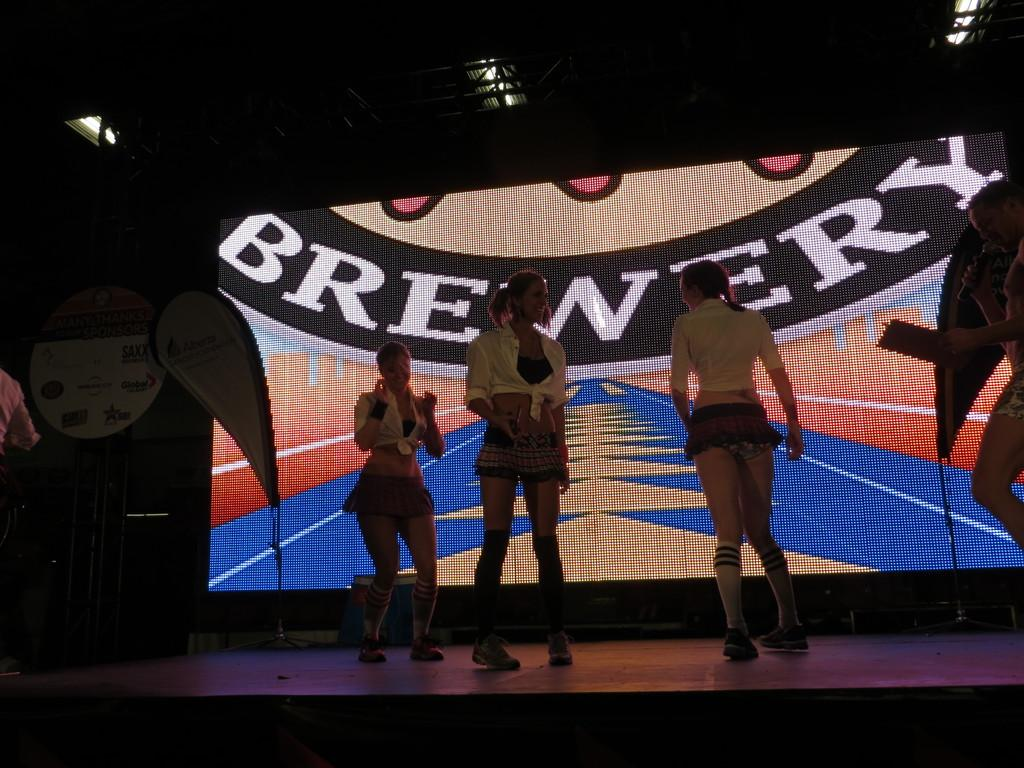What is happening on the stage in the image? There are women on the stage in the image. What is the person holding in his hand? The person is holding a mic and a paper in his hand. What can be seen hanging in the background? There are banners visible in the image. What is used for displaying information or visuals in the image? There is a screen present in the image. Can you tell me how many songs the person is reading from the paper in the image? There is no indication in the image that the person is reading songs from the paper; he is holding a mic and a paper, but the content of the paper is not specified. How does the person fly in the image? The person does not fly in the image; he is standing on the stage holding a mic and a paper. 